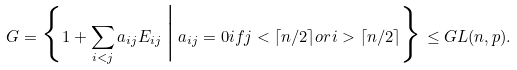<formula> <loc_0><loc_0><loc_500><loc_500>G = \Big \{ 1 + \sum _ { i < j } a _ { i j } E _ { i j } \, \Big | \, a _ { i j } = 0 i f j < \lceil n / 2 \rceil o r i > \lceil n / 2 \rceil \Big \} \leq G L ( n , p ) .</formula> 